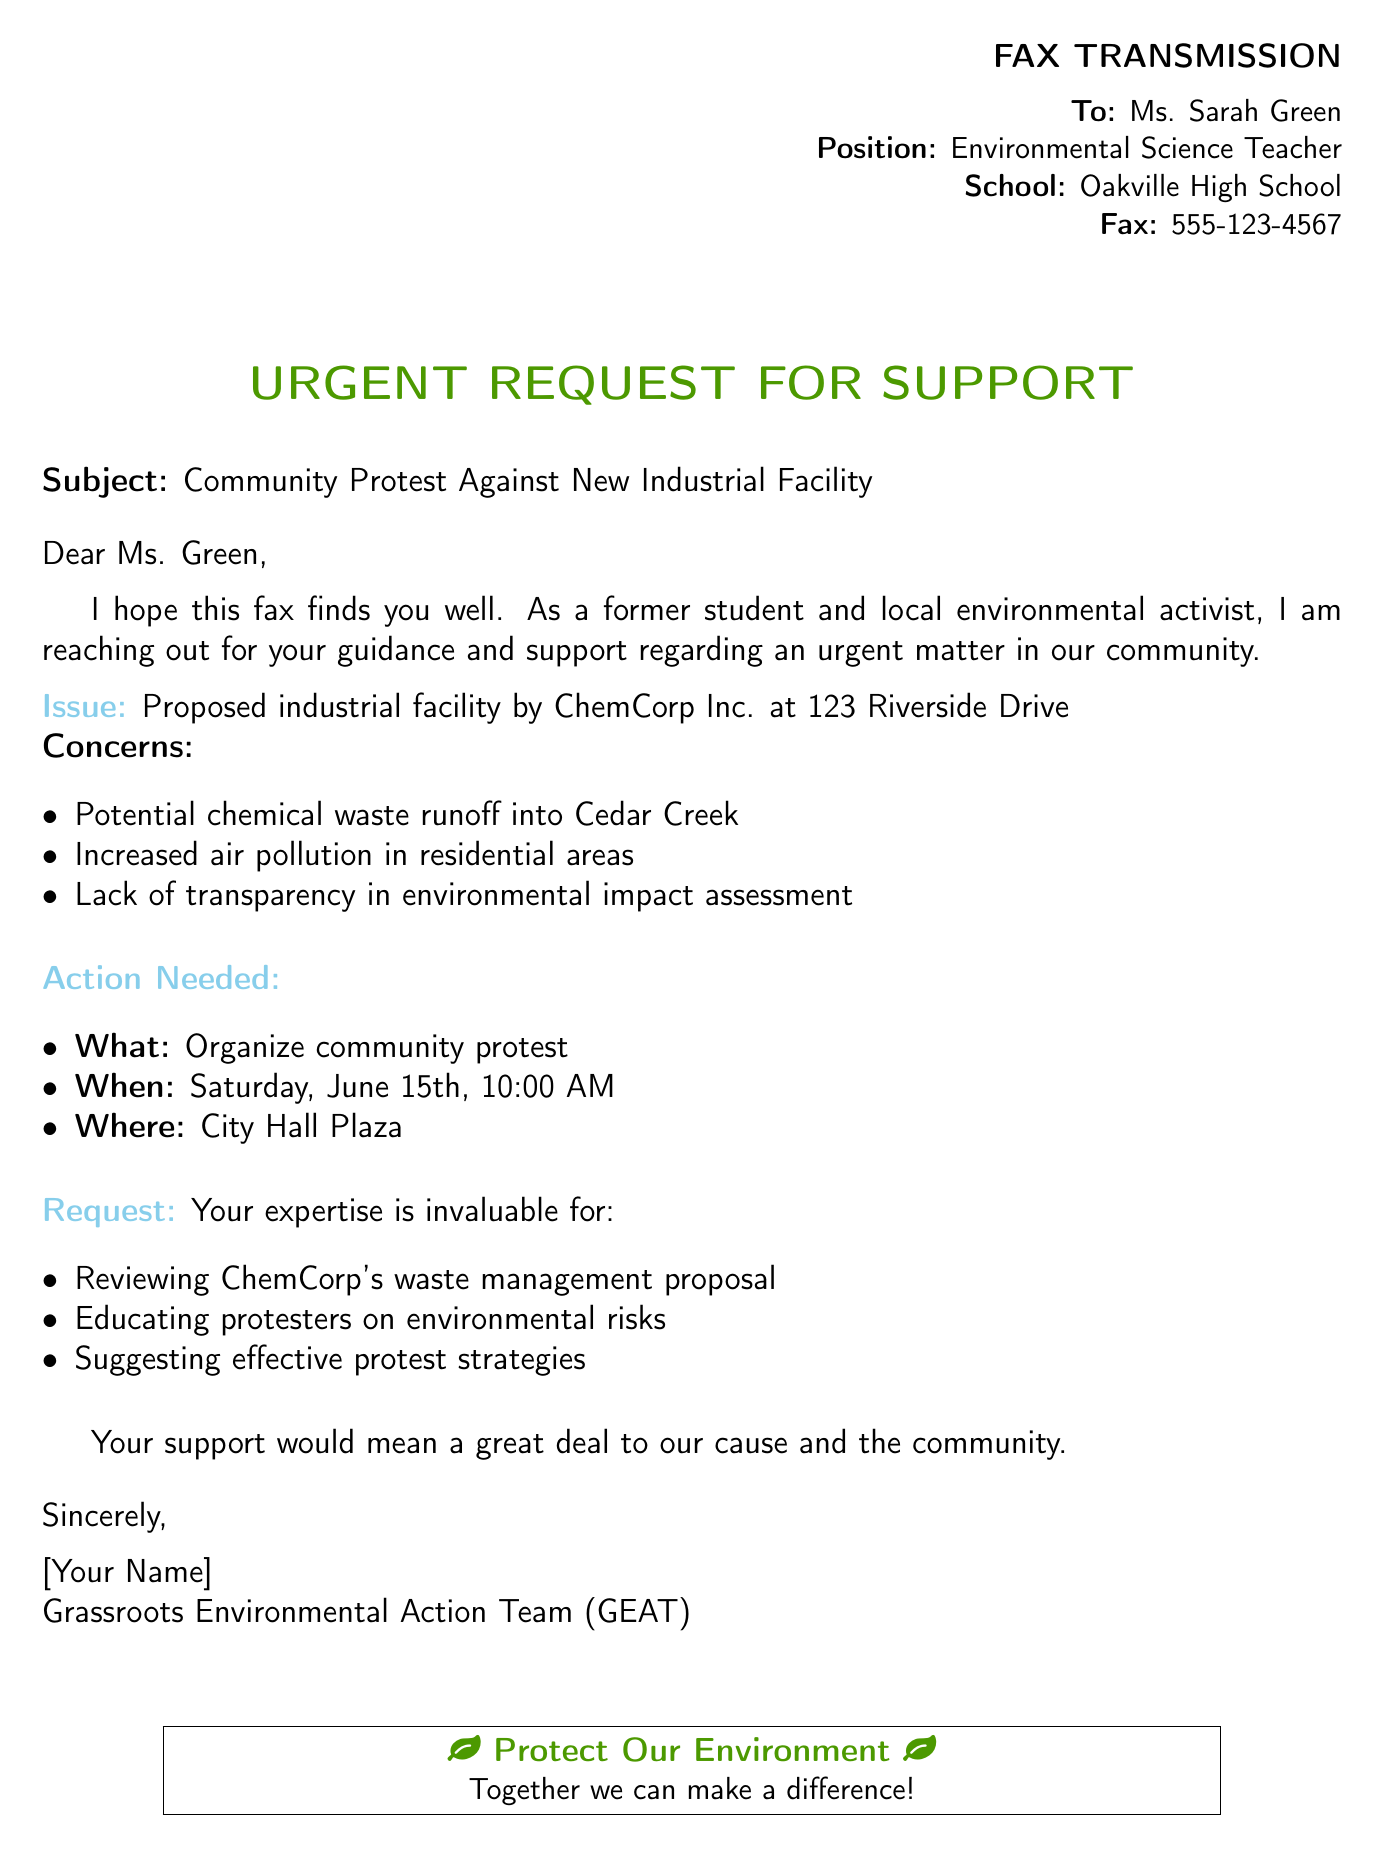what is the name of the proposed industrial facility? The name of the proposed industrial facility mentioned in the document is ChemCorp Inc.
Answer: ChemCorp Inc what is the location of the proposed facility? The document specifies the address of the proposed facility as 123 Riverside Drive.
Answer: 123 Riverside Drive when is the community protest scheduled? The document states that the community protest is scheduled for Saturday, June 15th.
Answer: Saturday, June 15th where will the protest take place? The protest is planned to take place at City Hall Plaza as mentioned in the document.
Answer: City Hall Plaza what is one of the concerns about the proposed facility? One of the listed concerns is potential chemical waste runoff into Cedar Creek.
Answer: chemical waste runoff what action is requested from Ms. Green? The document requests Ms. Green's expertise in reviewing ChemCorp's waste management proposal.
Answer: reviewing ChemCorp's waste management proposal who is the sender of the fax? The sender of the fax identifies themselves as a member of the Grassroots Environmental Action Team (GEAT).
Answer: Grassroots Environmental Action Team (GEAT) what is the purpose of the fax? The purpose of the fax is to request support for organizing a community protest against a new industrial facility.
Answer: support for organizing a community protest how is the fax formatted at the beginning? The fax is formatted with a header section detailing the recipient's name, position, school, and fax number in a flush right layout.
Answer: header section detailing recipient's information 